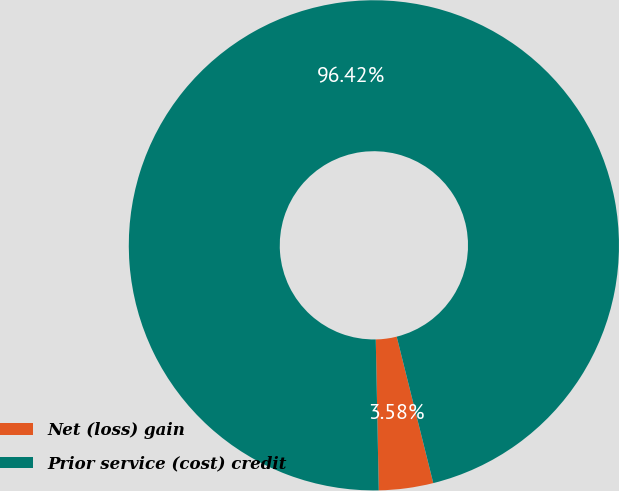<chart> <loc_0><loc_0><loc_500><loc_500><pie_chart><fcel>Net (loss) gain<fcel>Prior service (cost) credit<nl><fcel>3.58%<fcel>96.42%<nl></chart> 